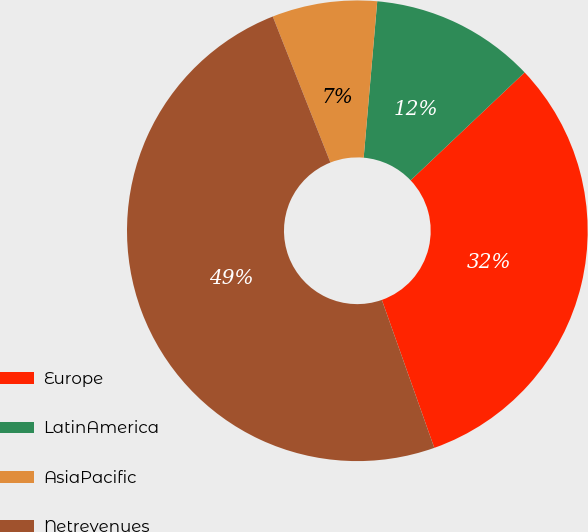<chart> <loc_0><loc_0><loc_500><loc_500><pie_chart><fcel>Europe<fcel>LatinAmerica<fcel>AsiaPacific<fcel>Netrevenues<nl><fcel>31.64%<fcel>11.56%<fcel>7.36%<fcel>49.44%<nl></chart> 